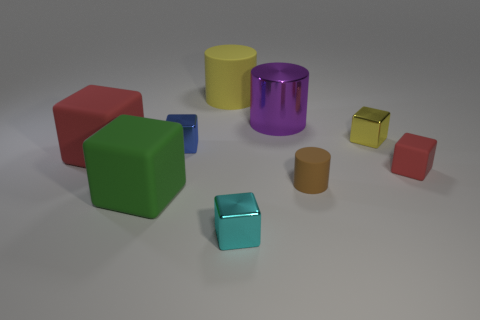There is a rubber thing behind the metal cube right of the tiny cyan thing; what size is it?
Your answer should be very brief. Large. What is the red object left of the blue shiny thing made of?
Provide a succinct answer. Rubber. What size is the cyan thing that is the same material as the blue object?
Offer a very short reply. Small. What number of green things have the same shape as the blue shiny object?
Offer a very short reply. 1. Does the small red rubber object have the same shape as the red object that is behind the tiny red rubber object?
Your answer should be very brief. Yes. Is there a small cyan cube that has the same material as the large yellow cylinder?
Your response must be concise. No. Is there any other thing that is made of the same material as the brown cylinder?
Make the answer very short. Yes. There is a red object behind the red object that is to the right of the green cube; what is it made of?
Provide a succinct answer. Rubber. There is a rubber object behind the red block to the left of the matte cylinder that is on the right side of the big yellow thing; what is its size?
Your response must be concise. Large. How many other things are the same shape as the small yellow object?
Keep it short and to the point. 5. 